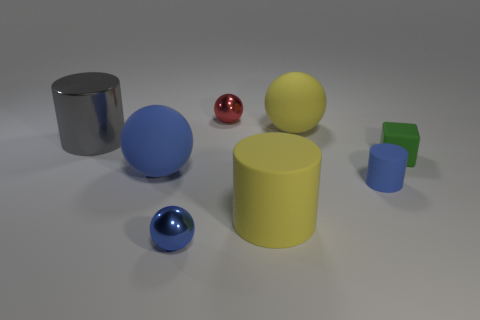There is a large sphere that is behind the small block; is its color the same as the large rubber cylinder?
Provide a succinct answer. Yes. Do the yellow sphere left of the cube and the big cylinder that is behind the small green rubber cube have the same material?
Provide a succinct answer. No. What size is the yellow thing to the right of the yellow cylinder?
Your response must be concise. Large. What is the material of the other small object that is the same shape as the red thing?
Provide a succinct answer. Metal. There is a small blue object that is to the right of the yellow matte sphere; what is its shape?
Provide a short and direct response. Cylinder. What number of large blue rubber objects are the same shape as the small green rubber object?
Your response must be concise. 0. Are there the same number of big yellow rubber objects behind the big blue ball and tiny green rubber blocks left of the blue cylinder?
Make the answer very short. No. Is there a big blue object that has the same material as the yellow cylinder?
Ensure brevity in your answer.  Yes. Is the material of the blue cylinder the same as the red thing?
Ensure brevity in your answer.  No. What number of gray objects are shiny cylinders or shiny things?
Offer a terse response. 1. 